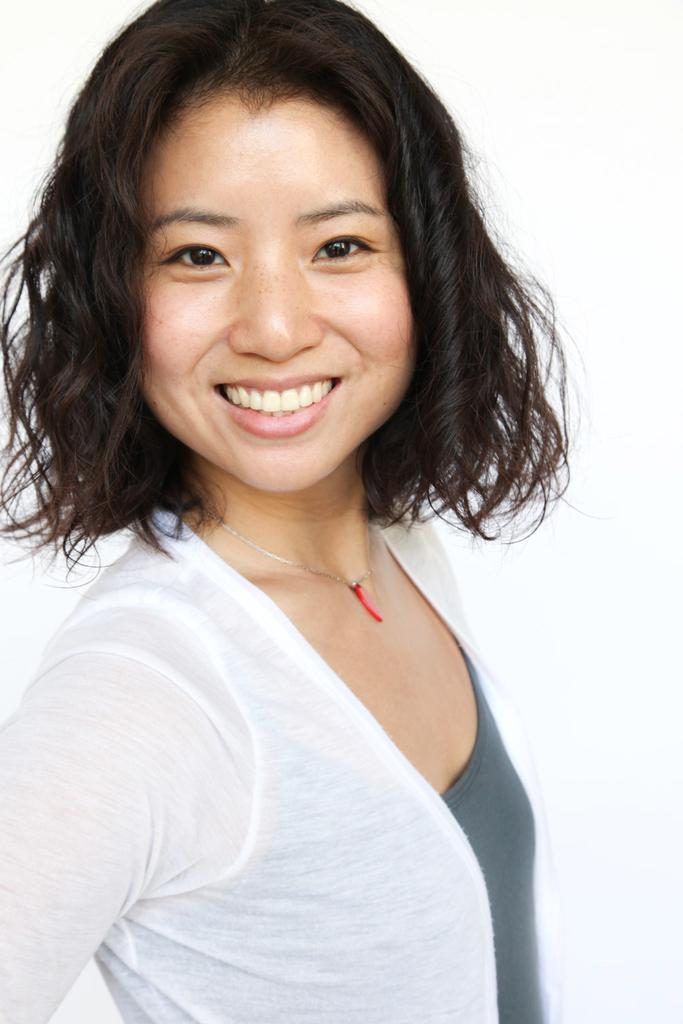Who is present in the image? There is a woman in the image. What colors are the woman's clothes? The woman is wearing white and gray color clothes. What type of love is the woman offering in the image? There is no indication of love or any offering in the image; it only shows a woman wearing white and gray clothes. 